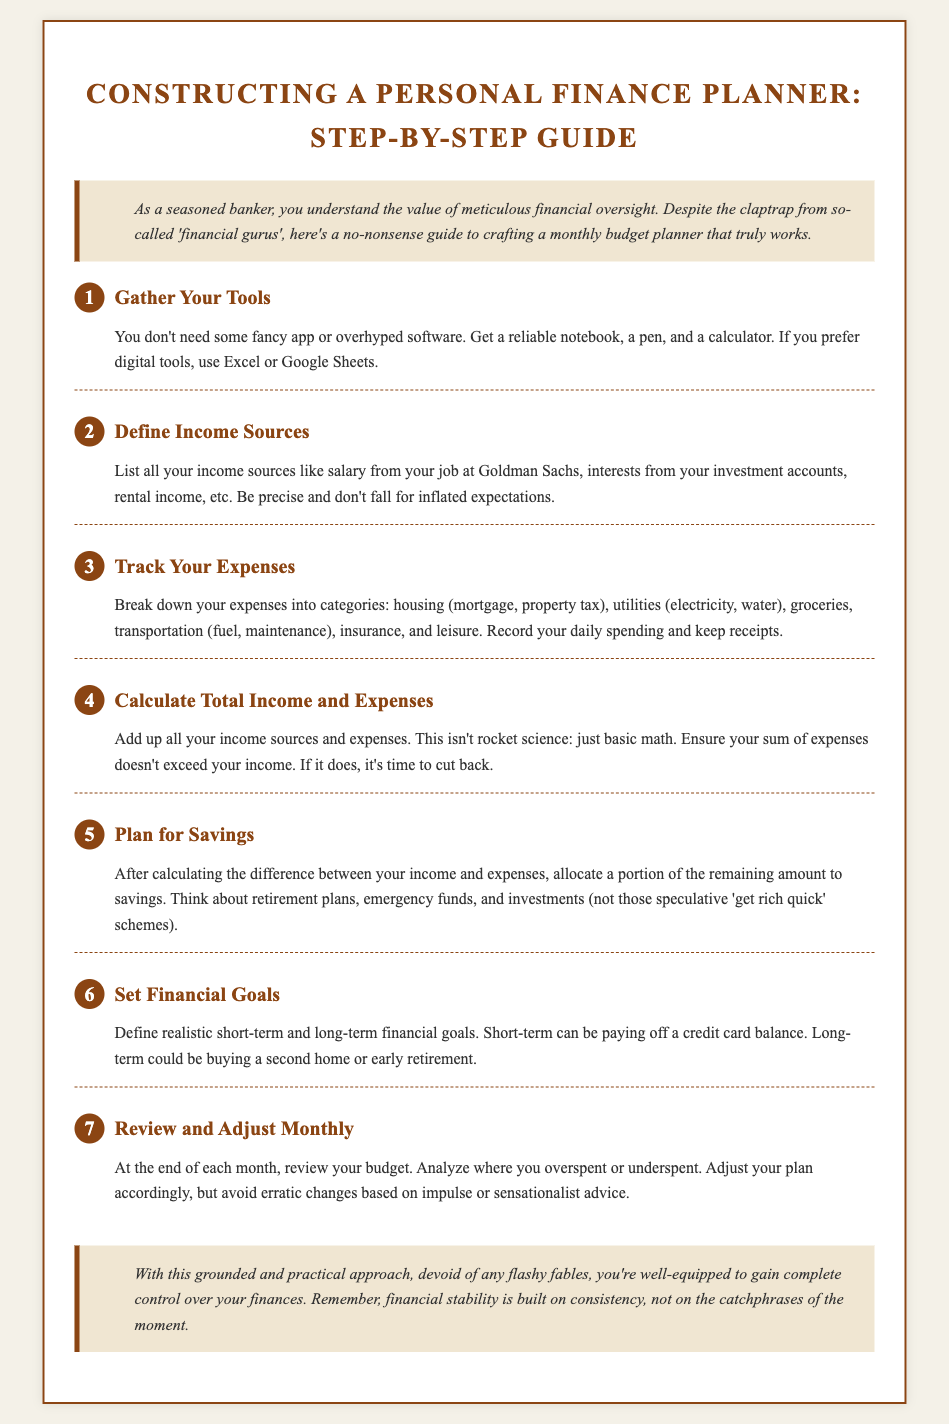What is the title of the document? The title is stated at the top of the document as "Constructing a Personal Finance Planner: Step-by-Step Guide."
Answer: Constructing a Personal Finance Planner: Step-by-Step Guide How many steps are outlined in the guide? The document lists a total of seven steps in constructing a personal finance planner.
Answer: 7 What is the first step in the planning process? The first step as per the document is "Gather Your Tools."
Answer: Gather Your Tools Which section advises on reviewing the budget? The section that advises reviewing the budget is titled "Review and Adjust Monthly."
Answer: Review and Adjust Monthly What should you list under income sources? The document suggests listing items like salary, interests from investment accounts, and rental income under income sources.
Answer: Salary, interests, rental income What is the purpose of the "Plan for Savings" step? The purpose of this step is to allocate a portion of the remaining amount after expenses to savings for things like retirement plans or emergency funds.
Answer: Allocate to savings What color is the background of the document? The background color of the document is a light beige, specifically noted as #f4f1e8.
Answer: Light beige What is advised against in the section for planning savings? The document advises against falling for 'get rich quick' schemes when planning for savings.
Answer: Get rich quick schemes 